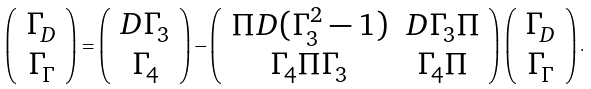<formula> <loc_0><loc_0><loc_500><loc_500>\left ( \begin{array} { c } \Gamma _ { D } \\ \Gamma _ { \Gamma } \end{array} \right ) = \left ( \begin{array} { c } D \Gamma _ { 3 } \\ \Gamma _ { 4 } \end{array} \right ) - \left ( \begin{array} { c c } \Pi D ( \Gamma _ { 3 } ^ { 2 } - 1 ) & D \Gamma _ { 3 } \Pi \\ \Gamma _ { 4 } \Pi \Gamma _ { 3 } & \Gamma _ { 4 } \Pi \end{array} \right ) \left ( \begin{array} { c } \Gamma _ { D } \\ \Gamma _ { \Gamma } \end{array} \right ) .</formula> 